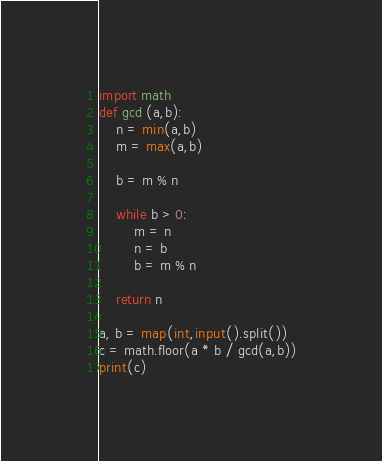Convert code to text. <code><loc_0><loc_0><loc_500><loc_500><_Python_>import math
def gcd (a,b):
    n = min(a,b)
    m = max(a,b)
    
    b = m % n
    
    while b > 0:
        m = n
        n = b
        b = m % n
    
    return n

a, b = map(int,input().split())
c = math.floor(a * b / gcd(a,b))
print(c)</code> 